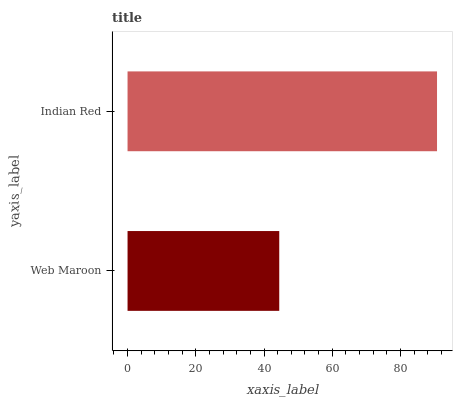Is Web Maroon the minimum?
Answer yes or no. Yes. Is Indian Red the maximum?
Answer yes or no. Yes. Is Indian Red the minimum?
Answer yes or no. No. Is Indian Red greater than Web Maroon?
Answer yes or no. Yes. Is Web Maroon less than Indian Red?
Answer yes or no. Yes. Is Web Maroon greater than Indian Red?
Answer yes or no. No. Is Indian Red less than Web Maroon?
Answer yes or no. No. Is Indian Red the high median?
Answer yes or no. Yes. Is Web Maroon the low median?
Answer yes or no. Yes. Is Web Maroon the high median?
Answer yes or no. No. Is Indian Red the low median?
Answer yes or no. No. 